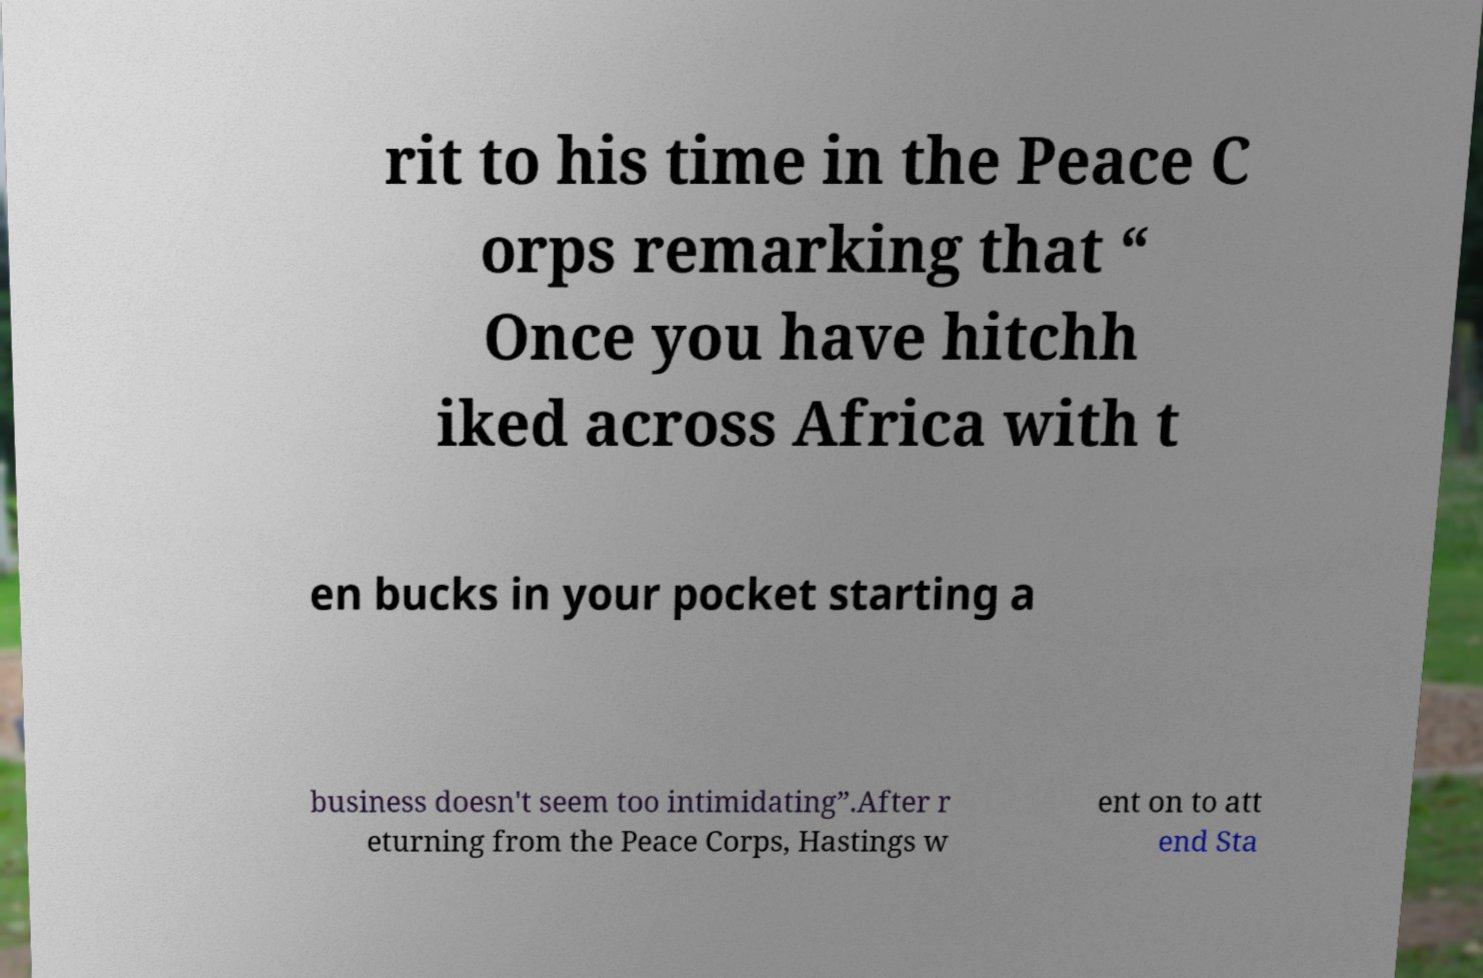Can you read and provide the text displayed in the image?This photo seems to have some interesting text. Can you extract and type it out for me? rit to his time in the Peace C orps remarking that “ Once you have hitchh iked across Africa with t en bucks in your pocket starting a business doesn't seem too intimidating”.After r eturning from the Peace Corps, Hastings w ent on to att end Sta 